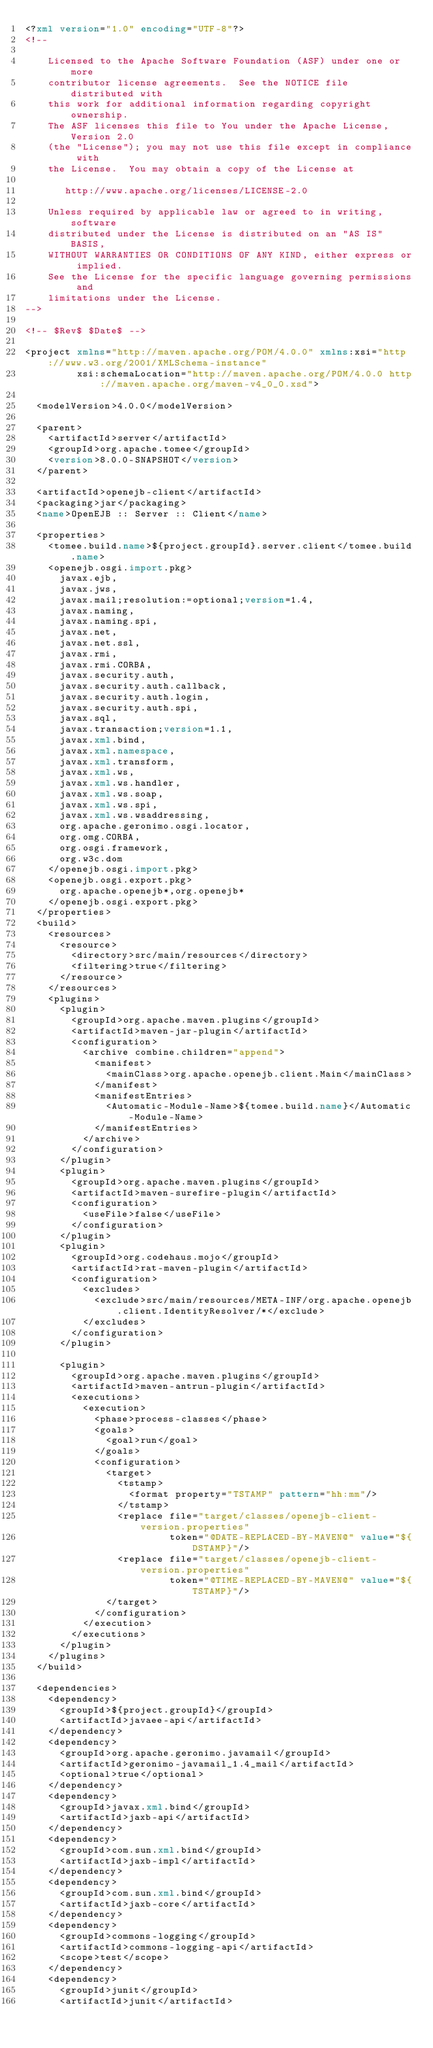Convert code to text. <code><loc_0><loc_0><loc_500><loc_500><_XML_><?xml version="1.0" encoding="UTF-8"?>
<!--

    Licensed to the Apache Software Foundation (ASF) under one or more
    contributor license agreements.  See the NOTICE file distributed with
    this work for additional information regarding copyright ownership.
    The ASF licenses this file to You under the Apache License, Version 2.0
    (the "License"); you may not use this file except in compliance with
    the License.  You may obtain a copy of the License at

       http://www.apache.org/licenses/LICENSE-2.0

    Unless required by applicable law or agreed to in writing, software
    distributed under the License is distributed on an "AS IS" BASIS,
    WITHOUT WARRANTIES OR CONDITIONS OF ANY KIND, either express or implied.
    See the License for the specific language governing permissions and
    limitations under the License.
-->

<!-- $Rev$ $Date$ -->

<project xmlns="http://maven.apache.org/POM/4.0.0" xmlns:xsi="http://www.w3.org/2001/XMLSchema-instance"
         xsi:schemaLocation="http://maven.apache.org/POM/4.0.0 http://maven.apache.org/maven-v4_0_0.xsd">

  <modelVersion>4.0.0</modelVersion>

  <parent>
    <artifactId>server</artifactId>
    <groupId>org.apache.tomee</groupId>
    <version>8.0.0-SNAPSHOT</version>
  </parent>

  <artifactId>openejb-client</artifactId>
  <packaging>jar</packaging>
  <name>OpenEJB :: Server :: Client</name>

  <properties>
    <tomee.build.name>${project.groupId}.server.client</tomee.build.name>
    <openejb.osgi.import.pkg>
      javax.ejb,
      javax.jws,
      javax.mail;resolution:=optional;version=1.4,
      javax.naming,
      javax.naming.spi,
      javax.net,
      javax.net.ssl,
      javax.rmi,
      javax.rmi.CORBA,
      javax.security.auth,
      javax.security.auth.callback,
      javax.security.auth.login,
      javax.security.auth.spi,
      javax.sql,
      javax.transaction;version=1.1,
      javax.xml.bind,
      javax.xml.namespace,
      javax.xml.transform,
      javax.xml.ws,
      javax.xml.ws.handler,
      javax.xml.ws.soap,
      javax.xml.ws.spi,
      javax.xml.ws.wsaddressing,
      org.apache.geronimo.osgi.locator,
      org.omg.CORBA,
      org.osgi.framework,
      org.w3c.dom
    </openejb.osgi.import.pkg>
    <openejb.osgi.export.pkg>
      org.apache.openejb*,org.openejb*
    </openejb.osgi.export.pkg>
  </properties>
  <build>
    <resources>
      <resource>
        <directory>src/main/resources</directory>
        <filtering>true</filtering>
      </resource>
    </resources>
    <plugins>
      <plugin>
        <groupId>org.apache.maven.plugins</groupId>
        <artifactId>maven-jar-plugin</artifactId>
        <configuration>
          <archive combine.children="append">
            <manifest>
              <mainClass>org.apache.openejb.client.Main</mainClass>
            </manifest>
            <manifestEntries>
              <Automatic-Module-Name>${tomee.build.name}</Automatic-Module-Name>
            </manifestEntries>
          </archive>
        </configuration>
      </plugin>
      <plugin>
        <groupId>org.apache.maven.plugins</groupId>
        <artifactId>maven-surefire-plugin</artifactId>
        <configuration>
          <useFile>false</useFile>
        </configuration>
      </plugin>
      <plugin>
        <groupId>org.codehaus.mojo</groupId>
        <artifactId>rat-maven-plugin</artifactId>
        <configuration>
          <excludes>
            <exclude>src/main/resources/META-INF/org.apache.openejb.client.IdentityResolver/*</exclude>
          </excludes>
        </configuration>
      </plugin>

      <plugin>
        <groupId>org.apache.maven.plugins</groupId>
        <artifactId>maven-antrun-plugin</artifactId>
        <executions>
          <execution>
            <phase>process-classes</phase>
            <goals>
              <goal>run</goal>
            </goals>
            <configuration>
              <target>
                <tstamp>
                  <format property="TSTAMP" pattern="hh:mm"/>
                </tstamp>
                <replace file="target/classes/openejb-client-version.properties"
                         token="@DATE-REPLACED-BY-MAVEN@" value="${DSTAMP}"/>
                <replace file="target/classes/openejb-client-version.properties"
                         token="@TIME-REPLACED-BY-MAVEN@" value="${TSTAMP}"/>
              </target>
            </configuration>
          </execution>
        </executions>
      </plugin>
    </plugins>
  </build>

  <dependencies>
    <dependency>
      <groupId>${project.groupId}</groupId>
      <artifactId>javaee-api</artifactId>
    </dependency>
    <dependency>
      <groupId>org.apache.geronimo.javamail</groupId>
      <artifactId>geronimo-javamail_1.4_mail</artifactId>
      <optional>true</optional>
    </dependency>
    <dependency>
      <groupId>javax.xml.bind</groupId>
      <artifactId>jaxb-api</artifactId>
    </dependency>
    <dependency>
      <groupId>com.sun.xml.bind</groupId>
      <artifactId>jaxb-impl</artifactId>
    </dependency>
    <dependency>
      <groupId>com.sun.xml.bind</groupId>
      <artifactId>jaxb-core</artifactId>
    </dependency>
    <dependency>
      <groupId>commons-logging</groupId>
      <artifactId>commons-logging-api</artifactId>
      <scope>test</scope>
    </dependency>
    <dependency>
      <groupId>junit</groupId>
      <artifactId>junit</artifactId></code> 